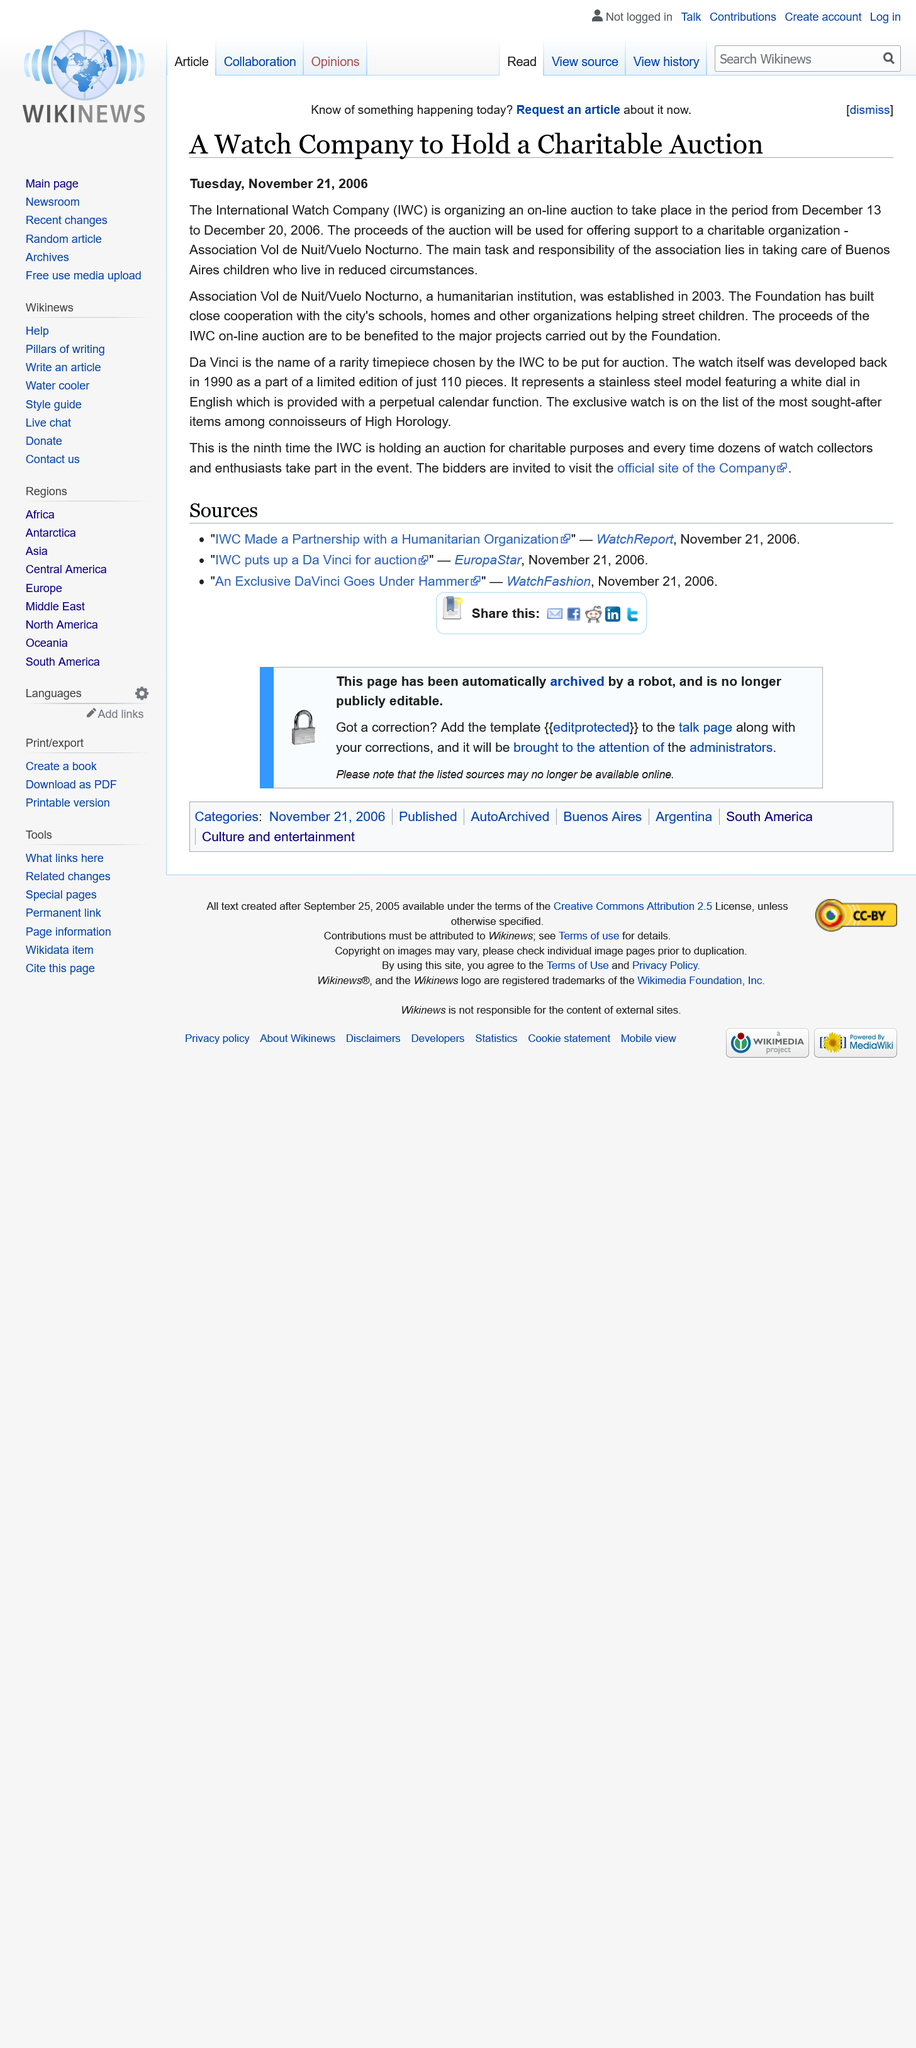Give some essential details in this illustration. The International Whaling Commission is organizing an online auction. The proceeds of the on-line auction conducted by the International Watch Company go to projects supported by the Association Vol de Nuit/Vuelo Nocturno foundation. The Association Vol de Nuit/Vuelo Nocturno was established in 2003. 